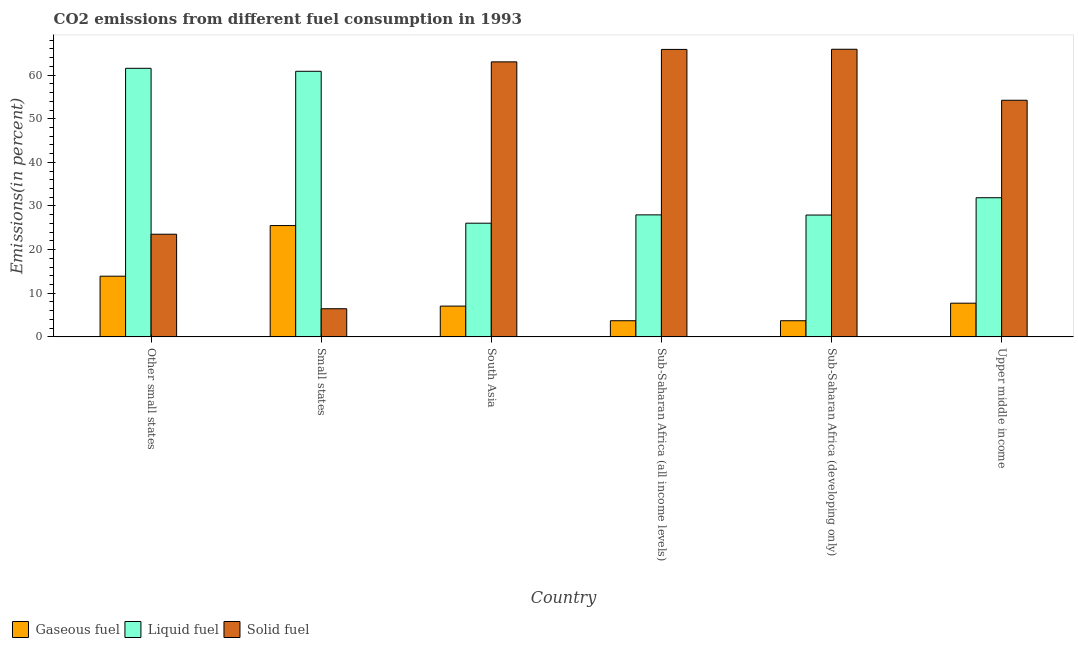Are the number of bars per tick equal to the number of legend labels?
Provide a short and direct response. Yes. In how many cases, is the number of bars for a given country not equal to the number of legend labels?
Offer a very short reply. 0. What is the percentage of gaseous fuel emission in Sub-Saharan Africa (all income levels)?
Make the answer very short. 3.7. Across all countries, what is the maximum percentage of liquid fuel emission?
Provide a short and direct response. 61.56. Across all countries, what is the minimum percentage of solid fuel emission?
Ensure brevity in your answer.  6.45. In which country was the percentage of liquid fuel emission maximum?
Ensure brevity in your answer.  Other small states. In which country was the percentage of gaseous fuel emission minimum?
Offer a terse response. Sub-Saharan Africa (all income levels). What is the total percentage of gaseous fuel emission in the graph?
Offer a very short reply. 61.59. What is the difference between the percentage of solid fuel emission in Sub-Saharan Africa (all income levels) and that in Sub-Saharan Africa (developing only)?
Make the answer very short. -0.04. What is the difference between the percentage of gaseous fuel emission in Sub-Saharan Africa (all income levels) and the percentage of solid fuel emission in Sub-Saharan Africa (developing only)?
Your answer should be compact. -62.22. What is the average percentage of gaseous fuel emission per country?
Your answer should be very brief. 10.27. What is the difference between the percentage of gaseous fuel emission and percentage of solid fuel emission in Small states?
Your response must be concise. 19.06. What is the ratio of the percentage of solid fuel emission in Sub-Saharan Africa (developing only) to that in Upper middle income?
Offer a terse response. 1.22. Is the difference between the percentage of gaseous fuel emission in Small states and South Asia greater than the difference between the percentage of liquid fuel emission in Small states and South Asia?
Make the answer very short. No. What is the difference between the highest and the second highest percentage of liquid fuel emission?
Your answer should be compact. 0.69. What is the difference between the highest and the lowest percentage of solid fuel emission?
Ensure brevity in your answer.  59.48. In how many countries, is the percentage of gaseous fuel emission greater than the average percentage of gaseous fuel emission taken over all countries?
Your answer should be very brief. 2. Is the sum of the percentage of liquid fuel emission in Sub-Saharan Africa (developing only) and Upper middle income greater than the maximum percentage of gaseous fuel emission across all countries?
Offer a very short reply. Yes. What does the 3rd bar from the left in Sub-Saharan Africa (developing only) represents?
Make the answer very short. Solid fuel. What does the 3rd bar from the right in Sub-Saharan Africa (developing only) represents?
Offer a terse response. Gaseous fuel. Is it the case that in every country, the sum of the percentage of gaseous fuel emission and percentage of liquid fuel emission is greater than the percentage of solid fuel emission?
Provide a succinct answer. No. Are all the bars in the graph horizontal?
Give a very brief answer. No. How many countries are there in the graph?
Your answer should be very brief. 6. What is the difference between two consecutive major ticks on the Y-axis?
Your answer should be very brief. 10. Are the values on the major ticks of Y-axis written in scientific E-notation?
Ensure brevity in your answer.  No. Does the graph contain grids?
Your answer should be very brief. No. How are the legend labels stacked?
Offer a very short reply. Horizontal. What is the title of the graph?
Provide a succinct answer. CO2 emissions from different fuel consumption in 1993. Does "Resident buildings and public services" appear as one of the legend labels in the graph?
Give a very brief answer. No. What is the label or title of the X-axis?
Keep it short and to the point. Country. What is the label or title of the Y-axis?
Keep it short and to the point. Emissions(in percent). What is the Emissions(in percent) of Gaseous fuel in Other small states?
Give a very brief answer. 13.91. What is the Emissions(in percent) of Liquid fuel in Other small states?
Ensure brevity in your answer.  61.56. What is the Emissions(in percent) of Solid fuel in Other small states?
Offer a very short reply. 23.53. What is the Emissions(in percent) in Gaseous fuel in Small states?
Your answer should be compact. 25.51. What is the Emissions(in percent) of Liquid fuel in Small states?
Your answer should be very brief. 60.87. What is the Emissions(in percent) in Solid fuel in Small states?
Keep it short and to the point. 6.45. What is the Emissions(in percent) of Gaseous fuel in South Asia?
Give a very brief answer. 7.05. What is the Emissions(in percent) in Liquid fuel in South Asia?
Provide a short and direct response. 26.05. What is the Emissions(in percent) of Solid fuel in South Asia?
Ensure brevity in your answer.  63.03. What is the Emissions(in percent) in Gaseous fuel in Sub-Saharan Africa (all income levels)?
Your response must be concise. 3.7. What is the Emissions(in percent) in Liquid fuel in Sub-Saharan Africa (all income levels)?
Provide a succinct answer. 27.96. What is the Emissions(in percent) in Solid fuel in Sub-Saharan Africa (all income levels)?
Your answer should be very brief. 65.89. What is the Emissions(in percent) in Gaseous fuel in Sub-Saharan Africa (developing only)?
Offer a very short reply. 3.7. What is the Emissions(in percent) in Liquid fuel in Sub-Saharan Africa (developing only)?
Provide a short and direct response. 27.92. What is the Emissions(in percent) of Solid fuel in Sub-Saharan Africa (developing only)?
Keep it short and to the point. 65.92. What is the Emissions(in percent) of Gaseous fuel in Upper middle income?
Give a very brief answer. 7.72. What is the Emissions(in percent) of Liquid fuel in Upper middle income?
Ensure brevity in your answer.  31.89. What is the Emissions(in percent) of Solid fuel in Upper middle income?
Provide a short and direct response. 54.23. Across all countries, what is the maximum Emissions(in percent) of Gaseous fuel?
Your answer should be very brief. 25.51. Across all countries, what is the maximum Emissions(in percent) in Liquid fuel?
Make the answer very short. 61.56. Across all countries, what is the maximum Emissions(in percent) of Solid fuel?
Your response must be concise. 65.92. Across all countries, what is the minimum Emissions(in percent) in Gaseous fuel?
Keep it short and to the point. 3.7. Across all countries, what is the minimum Emissions(in percent) of Liquid fuel?
Offer a very short reply. 26.05. Across all countries, what is the minimum Emissions(in percent) of Solid fuel?
Provide a succinct answer. 6.45. What is the total Emissions(in percent) of Gaseous fuel in the graph?
Make the answer very short. 61.59. What is the total Emissions(in percent) of Liquid fuel in the graph?
Your response must be concise. 236.27. What is the total Emissions(in percent) in Solid fuel in the graph?
Your response must be concise. 279.05. What is the difference between the Emissions(in percent) of Gaseous fuel in Other small states and that in Small states?
Offer a very short reply. -11.6. What is the difference between the Emissions(in percent) in Liquid fuel in Other small states and that in Small states?
Offer a very short reply. 0.69. What is the difference between the Emissions(in percent) of Solid fuel in Other small states and that in Small states?
Ensure brevity in your answer.  17.08. What is the difference between the Emissions(in percent) of Gaseous fuel in Other small states and that in South Asia?
Offer a very short reply. 6.85. What is the difference between the Emissions(in percent) of Liquid fuel in Other small states and that in South Asia?
Your response must be concise. 35.5. What is the difference between the Emissions(in percent) of Solid fuel in Other small states and that in South Asia?
Keep it short and to the point. -39.51. What is the difference between the Emissions(in percent) of Gaseous fuel in Other small states and that in Sub-Saharan Africa (all income levels)?
Provide a short and direct response. 10.21. What is the difference between the Emissions(in percent) of Liquid fuel in Other small states and that in Sub-Saharan Africa (all income levels)?
Your answer should be very brief. 33.59. What is the difference between the Emissions(in percent) in Solid fuel in Other small states and that in Sub-Saharan Africa (all income levels)?
Your answer should be compact. -42.36. What is the difference between the Emissions(in percent) in Gaseous fuel in Other small states and that in Sub-Saharan Africa (developing only)?
Keep it short and to the point. 10.21. What is the difference between the Emissions(in percent) in Liquid fuel in Other small states and that in Sub-Saharan Africa (developing only)?
Ensure brevity in your answer.  33.63. What is the difference between the Emissions(in percent) in Solid fuel in Other small states and that in Sub-Saharan Africa (developing only)?
Your response must be concise. -42.4. What is the difference between the Emissions(in percent) in Gaseous fuel in Other small states and that in Upper middle income?
Your answer should be very brief. 6.18. What is the difference between the Emissions(in percent) of Liquid fuel in Other small states and that in Upper middle income?
Keep it short and to the point. 29.66. What is the difference between the Emissions(in percent) of Solid fuel in Other small states and that in Upper middle income?
Make the answer very short. -30.71. What is the difference between the Emissions(in percent) of Gaseous fuel in Small states and that in South Asia?
Your answer should be compact. 18.46. What is the difference between the Emissions(in percent) of Liquid fuel in Small states and that in South Asia?
Offer a very short reply. 34.82. What is the difference between the Emissions(in percent) in Solid fuel in Small states and that in South Asia?
Keep it short and to the point. -56.59. What is the difference between the Emissions(in percent) of Gaseous fuel in Small states and that in Sub-Saharan Africa (all income levels)?
Give a very brief answer. 21.81. What is the difference between the Emissions(in percent) in Liquid fuel in Small states and that in Sub-Saharan Africa (all income levels)?
Make the answer very short. 32.91. What is the difference between the Emissions(in percent) in Solid fuel in Small states and that in Sub-Saharan Africa (all income levels)?
Your response must be concise. -59.44. What is the difference between the Emissions(in percent) in Gaseous fuel in Small states and that in Sub-Saharan Africa (developing only)?
Provide a short and direct response. 21.81. What is the difference between the Emissions(in percent) in Liquid fuel in Small states and that in Sub-Saharan Africa (developing only)?
Your answer should be compact. 32.95. What is the difference between the Emissions(in percent) in Solid fuel in Small states and that in Sub-Saharan Africa (developing only)?
Keep it short and to the point. -59.48. What is the difference between the Emissions(in percent) in Gaseous fuel in Small states and that in Upper middle income?
Offer a very short reply. 17.79. What is the difference between the Emissions(in percent) of Liquid fuel in Small states and that in Upper middle income?
Offer a very short reply. 28.98. What is the difference between the Emissions(in percent) in Solid fuel in Small states and that in Upper middle income?
Your answer should be very brief. -47.79. What is the difference between the Emissions(in percent) of Gaseous fuel in South Asia and that in Sub-Saharan Africa (all income levels)?
Give a very brief answer. 3.35. What is the difference between the Emissions(in percent) of Liquid fuel in South Asia and that in Sub-Saharan Africa (all income levels)?
Provide a short and direct response. -1.91. What is the difference between the Emissions(in percent) of Solid fuel in South Asia and that in Sub-Saharan Africa (all income levels)?
Make the answer very short. -2.85. What is the difference between the Emissions(in percent) in Gaseous fuel in South Asia and that in Sub-Saharan Africa (developing only)?
Your answer should be compact. 3.35. What is the difference between the Emissions(in percent) in Liquid fuel in South Asia and that in Sub-Saharan Africa (developing only)?
Your answer should be compact. -1.87. What is the difference between the Emissions(in percent) of Solid fuel in South Asia and that in Sub-Saharan Africa (developing only)?
Your answer should be compact. -2.89. What is the difference between the Emissions(in percent) in Gaseous fuel in South Asia and that in Upper middle income?
Make the answer very short. -0.67. What is the difference between the Emissions(in percent) in Liquid fuel in South Asia and that in Upper middle income?
Your answer should be compact. -5.84. What is the difference between the Emissions(in percent) in Solid fuel in South Asia and that in Upper middle income?
Give a very brief answer. 8.8. What is the difference between the Emissions(in percent) in Gaseous fuel in Sub-Saharan Africa (all income levels) and that in Sub-Saharan Africa (developing only)?
Keep it short and to the point. -0. What is the difference between the Emissions(in percent) of Liquid fuel in Sub-Saharan Africa (all income levels) and that in Sub-Saharan Africa (developing only)?
Make the answer very short. 0.04. What is the difference between the Emissions(in percent) of Solid fuel in Sub-Saharan Africa (all income levels) and that in Sub-Saharan Africa (developing only)?
Give a very brief answer. -0.04. What is the difference between the Emissions(in percent) in Gaseous fuel in Sub-Saharan Africa (all income levels) and that in Upper middle income?
Give a very brief answer. -4.02. What is the difference between the Emissions(in percent) of Liquid fuel in Sub-Saharan Africa (all income levels) and that in Upper middle income?
Provide a succinct answer. -3.93. What is the difference between the Emissions(in percent) of Solid fuel in Sub-Saharan Africa (all income levels) and that in Upper middle income?
Provide a succinct answer. 11.65. What is the difference between the Emissions(in percent) in Gaseous fuel in Sub-Saharan Africa (developing only) and that in Upper middle income?
Make the answer very short. -4.02. What is the difference between the Emissions(in percent) of Liquid fuel in Sub-Saharan Africa (developing only) and that in Upper middle income?
Ensure brevity in your answer.  -3.97. What is the difference between the Emissions(in percent) in Solid fuel in Sub-Saharan Africa (developing only) and that in Upper middle income?
Ensure brevity in your answer.  11.69. What is the difference between the Emissions(in percent) in Gaseous fuel in Other small states and the Emissions(in percent) in Liquid fuel in Small states?
Your answer should be compact. -46.97. What is the difference between the Emissions(in percent) of Gaseous fuel in Other small states and the Emissions(in percent) of Solid fuel in Small states?
Your response must be concise. 7.46. What is the difference between the Emissions(in percent) in Liquid fuel in Other small states and the Emissions(in percent) in Solid fuel in Small states?
Provide a short and direct response. 55.11. What is the difference between the Emissions(in percent) of Gaseous fuel in Other small states and the Emissions(in percent) of Liquid fuel in South Asia?
Keep it short and to the point. -12.15. What is the difference between the Emissions(in percent) of Gaseous fuel in Other small states and the Emissions(in percent) of Solid fuel in South Asia?
Offer a terse response. -49.13. What is the difference between the Emissions(in percent) in Liquid fuel in Other small states and the Emissions(in percent) in Solid fuel in South Asia?
Keep it short and to the point. -1.48. What is the difference between the Emissions(in percent) in Gaseous fuel in Other small states and the Emissions(in percent) in Liquid fuel in Sub-Saharan Africa (all income levels)?
Your response must be concise. -14.06. What is the difference between the Emissions(in percent) of Gaseous fuel in Other small states and the Emissions(in percent) of Solid fuel in Sub-Saharan Africa (all income levels)?
Your answer should be compact. -51.98. What is the difference between the Emissions(in percent) of Liquid fuel in Other small states and the Emissions(in percent) of Solid fuel in Sub-Saharan Africa (all income levels)?
Give a very brief answer. -4.33. What is the difference between the Emissions(in percent) of Gaseous fuel in Other small states and the Emissions(in percent) of Liquid fuel in Sub-Saharan Africa (developing only)?
Your answer should be very brief. -14.02. What is the difference between the Emissions(in percent) of Gaseous fuel in Other small states and the Emissions(in percent) of Solid fuel in Sub-Saharan Africa (developing only)?
Make the answer very short. -52.02. What is the difference between the Emissions(in percent) of Liquid fuel in Other small states and the Emissions(in percent) of Solid fuel in Sub-Saharan Africa (developing only)?
Your answer should be compact. -4.37. What is the difference between the Emissions(in percent) in Gaseous fuel in Other small states and the Emissions(in percent) in Liquid fuel in Upper middle income?
Your answer should be very brief. -17.99. What is the difference between the Emissions(in percent) in Gaseous fuel in Other small states and the Emissions(in percent) in Solid fuel in Upper middle income?
Ensure brevity in your answer.  -40.33. What is the difference between the Emissions(in percent) of Liquid fuel in Other small states and the Emissions(in percent) of Solid fuel in Upper middle income?
Ensure brevity in your answer.  7.32. What is the difference between the Emissions(in percent) of Gaseous fuel in Small states and the Emissions(in percent) of Liquid fuel in South Asia?
Provide a short and direct response. -0.54. What is the difference between the Emissions(in percent) of Gaseous fuel in Small states and the Emissions(in percent) of Solid fuel in South Asia?
Provide a short and direct response. -37.52. What is the difference between the Emissions(in percent) in Liquid fuel in Small states and the Emissions(in percent) in Solid fuel in South Asia?
Provide a succinct answer. -2.16. What is the difference between the Emissions(in percent) in Gaseous fuel in Small states and the Emissions(in percent) in Liquid fuel in Sub-Saharan Africa (all income levels)?
Offer a terse response. -2.45. What is the difference between the Emissions(in percent) of Gaseous fuel in Small states and the Emissions(in percent) of Solid fuel in Sub-Saharan Africa (all income levels)?
Ensure brevity in your answer.  -40.38. What is the difference between the Emissions(in percent) of Liquid fuel in Small states and the Emissions(in percent) of Solid fuel in Sub-Saharan Africa (all income levels)?
Your answer should be compact. -5.01. What is the difference between the Emissions(in percent) of Gaseous fuel in Small states and the Emissions(in percent) of Liquid fuel in Sub-Saharan Africa (developing only)?
Your response must be concise. -2.41. What is the difference between the Emissions(in percent) in Gaseous fuel in Small states and the Emissions(in percent) in Solid fuel in Sub-Saharan Africa (developing only)?
Your response must be concise. -40.41. What is the difference between the Emissions(in percent) of Liquid fuel in Small states and the Emissions(in percent) of Solid fuel in Sub-Saharan Africa (developing only)?
Ensure brevity in your answer.  -5.05. What is the difference between the Emissions(in percent) of Gaseous fuel in Small states and the Emissions(in percent) of Liquid fuel in Upper middle income?
Your response must be concise. -6.38. What is the difference between the Emissions(in percent) in Gaseous fuel in Small states and the Emissions(in percent) in Solid fuel in Upper middle income?
Your answer should be compact. -28.72. What is the difference between the Emissions(in percent) in Liquid fuel in Small states and the Emissions(in percent) in Solid fuel in Upper middle income?
Provide a short and direct response. 6.64. What is the difference between the Emissions(in percent) in Gaseous fuel in South Asia and the Emissions(in percent) in Liquid fuel in Sub-Saharan Africa (all income levels)?
Make the answer very short. -20.91. What is the difference between the Emissions(in percent) of Gaseous fuel in South Asia and the Emissions(in percent) of Solid fuel in Sub-Saharan Africa (all income levels)?
Offer a very short reply. -58.83. What is the difference between the Emissions(in percent) of Liquid fuel in South Asia and the Emissions(in percent) of Solid fuel in Sub-Saharan Africa (all income levels)?
Ensure brevity in your answer.  -39.83. What is the difference between the Emissions(in percent) of Gaseous fuel in South Asia and the Emissions(in percent) of Liquid fuel in Sub-Saharan Africa (developing only)?
Offer a terse response. -20.87. What is the difference between the Emissions(in percent) in Gaseous fuel in South Asia and the Emissions(in percent) in Solid fuel in Sub-Saharan Africa (developing only)?
Keep it short and to the point. -58.87. What is the difference between the Emissions(in percent) in Liquid fuel in South Asia and the Emissions(in percent) in Solid fuel in Sub-Saharan Africa (developing only)?
Give a very brief answer. -39.87. What is the difference between the Emissions(in percent) in Gaseous fuel in South Asia and the Emissions(in percent) in Liquid fuel in Upper middle income?
Offer a terse response. -24.84. What is the difference between the Emissions(in percent) of Gaseous fuel in South Asia and the Emissions(in percent) of Solid fuel in Upper middle income?
Provide a short and direct response. -47.18. What is the difference between the Emissions(in percent) in Liquid fuel in South Asia and the Emissions(in percent) in Solid fuel in Upper middle income?
Provide a succinct answer. -28.18. What is the difference between the Emissions(in percent) of Gaseous fuel in Sub-Saharan Africa (all income levels) and the Emissions(in percent) of Liquid fuel in Sub-Saharan Africa (developing only)?
Give a very brief answer. -24.22. What is the difference between the Emissions(in percent) in Gaseous fuel in Sub-Saharan Africa (all income levels) and the Emissions(in percent) in Solid fuel in Sub-Saharan Africa (developing only)?
Offer a terse response. -62.22. What is the difference between the Emissions(in percent) in Liquid fuel in Sub-Saharan Africa (all income levels) and the Emissions(in percent) in Solid fuel in Sub-Saharan Africa (developing only)?
Offer a terse response. -37.96. What is the difference between the Emissions(in percent) in Gaseous fuel in Sub-Saharan Africa (all income levels) and the Emissions(in percent) in Liquid fuel in Upper middle income?
Your response must be concise. -28.19. What is the difference between the Emissions(in percent) in Gaseous fuel in Sub-Saharan Africa (all income levels) and the Emissions(in percent) in Solid fuel in Upper middle income?
Make the answer very short. -50.53. What is the difference between the Emissions(in percent) in Liquid fuel in Sub-Saharan Africa (all income levels) and the Emissions(in percent) in Solid fuel in Upper middle income?
Offer a terse response. -26.27. What is the difference between the Emissions(in percent) of Gaseous fuel in Sub-Saharan Africa (developing only) and the Emissions(in percent) of Liquid fuel in Upper middle income?
Offer a terse response. -28.19. What is the difference between the Emissions(in percent) in Gaseous fuel in Sub-Saharan Africa (developing only) and the Emissions(in percent) in Solid fuel in Upper middle income?
Offer a terse response. -50.53. What is the difference between the Emissions(in percent) in Liquid fuel in Sub-Saharan Africa (developing only) and the Emissions(in percent) in Solid fuel in Upper middle income?
Make the answer very short. -26.31. What is the average Emissions(in percent) of Gaseous fuel per country?
Your answer should be compact. 10.27. What is the average Emissions(in percent) in Liquid fuel per country?
Provide a succinct answer. 39.38. What is the average Emissions(in percent) of Solid fuel per country?
Your answer should be compact. 46.51. What is the difference between the Emissions(in percent) of Gaseous fuel and Emissions(in percent) of Liquid fuel in Other small states?
Your response must be concise. -47.65. What is the difference between the Emissions(in percent) in Gaseous fuel and Emissions(in percent) in Solid fuel in Other small states?
Your answer should be compact. -9.62. What is the difference between the Emissions(in percent) in Liquid fuel and Emissions(in percent) in Solid fuel in Other small states?
Provide a short and direct response. 38.03. What is the difference between the Emissions(in percent) of Gaseous fuel and Emissions(in percent) of Liquid fuel in Small states?
Give a very brief answer. -35.36. What is the difference between the Emissions(in percent) of Gaseous fuel and Emissions(in percent) of Solid fuel in Small states?
Provide a short and direct response. 19.06. What is the difference between the Emissions(in percent) in Liquid fuel and Emissions(in percent) in Solid fuel in Small states?
Your answer should be very brief. 54.43. What is the difference between the Emissions(in percent) of Gaseous fuel and Emissions(in percent) of Liquid fuel in South Asia?
Provide a short and direct response. -19. What is the difference between the Emissions(in percent) in Gaseous fuel and Emissions(in percent) in Solid fuel in South Asia?
Provide a succinct answer. -55.98. What is the difference between the Emissions(in percent) of Liquid fuel and Emissions(in percent) of Solid fuel in South Asia?
Ensure brevity in your answer.  -36.98. What is the difference between the Emissions(in percent) of Gaseous fuel and Emissions(in percent) of Liquid fuel in Sub-Saharan Africa (all income levels)?
Offer a very short reply. -24.27. What is the difference between the Emissions(in percent) of Gaseous fuel and Emissions(in percent) of Solid fuel in Sub-Saharan Africa (all income levels)?
Give a very brief answer. -62.19. What is the difference between the Emissions(in percent) in Liquid fuel and Emissions(in percent) in Solid fuel in Sub-Saharan Africa (all income levels)?
Make the answer very short. -37.92. What is the difference between the Emissions(in percent) of Gaseous fuel and Emissions(in percent) of Liquid fuel in Sub-Saharan Africa (developing only)?
Provide a short and direct response. -24.22. What is the difference between the Emissions(in percent) in Gaseous fuel and Emissions(in percent) in Solid fuel in Sub-Saharan Africa (developing only)?
Keep it short and to the point. -62.22. What is the difference between the Emissions(in percent) of Liquid fuel and Emissions(in percent) of Solid fuel in Sub-Saharan Africa (developing only)?
Offer a very short reply. -38. What is the difference between the Emissions(in percent) in Gaseous fuel and Emissions(in percent) in Liquid fuel in Upper middle income?
Keep it short and to the point. -24.17. What is the difference between the Emissions(in percent) of Gaseous fuel and Emissions(in percent) of Solid fuel in Upper middle income?
Your answer should be compact. -46.51. What is the difference between the Emissions(in percent) of Liquid fuel and Emissions(in percent) of Solid fuel in Upper middle income?
Your answer should be very brief. -22.34. What is the ratio of the Emissions(in percent) of Gaseous fuel in Other small states to that in Small states?
Offer a terse response. 0.55. What is the ratio of the Emissions(in percent) of Liquid fuel in Other small states to that in Small states?
Offer a very short reply. 1.01. What is the ratio of the Emissions(in percent) of Solid fuel in Other small states to that in Small states?
Ensure brevity in your answer.  3.65. What is the ratio of the Emissions(in percent) in Gaseous fuel in Other small states to that in South Asia?
Your response must be concise. 1.97. What is the ratio of the Emissions(in percent) of Liquid fuel in Other small states to that in South Asia?
Keep it short and to the point. 2.36. What is the ratio of the Emissions(in percent) in Solid fuel in Other small states to that in South Asia?
Keep it short and to the point. 0.37. What is the ratio of the Emissions(in percent) of Gaseous fuel in Other small states to that in Sub-Saharan Africa (all income levels)?
Your answer should be very brief. 3.76. What is the ratio of the Emissions(in percent) of Liquid fuel in Other small states to that in Sub-Saharan Africa (all income levels)?
Your answer should be compact. 2.2. What is the ratio of the Emissions(in percent) of Solid fuel in Other small states to that in Sub-Saharan Africa (all income levels)?
Your response must be concise. 0.36. What is the ratio of the Emissions(in percent) in Gaseous fuel in Other small states to that in Sub-Saharan Africa (developing only)?
Your answer should be very brief. 3.76. What is the ratio of the Emissions(in percent) of Liquid fuel in Other small states to that in Sub-Saharan Africa (developing only)?
Offer a very short reply. 2.2. What is the ratio of the Emissions(in percent) in Solid fuel in Other small states to that in Sub-Saharan Africa (developing only)?
Make the answer very short. 0.36. What is the ratio of the Emissions(in percent) in Gaseous fuel in Other small states to that in Upper middle income?
Provide a succinct answer. 1.8. What is the ratio of the Emissions(in percent) of Liquid fuel in Other small states to that in Upper middle income?
Your response must be concise. 1.93. What is the ratio of the Emissions(in percent) of Solid fuel in Other small states to that in Upper middle income?
Your answer should be very brief. 0.43. What is the ratio of the Emissions(in percent) of Gaseous fuel in Small states to that in South Asia?
Keep it short and to the point. 3.62. What is the ratio of the Emissions(in percent) in Liquid fuel in Small states to that in South Asia?
Offer a very short reply. 2.34. What is the ratio of the Emissions(in percent) of Solid fuel in Small states to that in South Asia?
Offer a terse response. 0.1. What is the ratio of the Emissions(in percent) in Gaseous fuel in Small states to that in Sub-Saharan Africa (all income levels)?
Make the answer very short. 6.9. What is the ratio of the Emissions(in percent) of Liquid fuel in Small states to that in Sub-Saharan Africa (all income levels)?
Offer a terse response. 2.18. What is the ratio of the Emissions(in percent) in Solid fuel in Small states to that in Sub-Saharan Africa (all income levels)?
Your response must be concise. 0.1. What is the ratio of the Emissions(in percent) of Gaseous fuel in Small states to that in Sub-Saharan Africa (developing only)?
Provide a short and direct response. 6.89. What is the ratio of the Emissions(in percent) of Liquid fuel in Small states to that in Sub-Saharan Africa (developing only)?
Your answer should be compact. 2.18. What is the ratio of the Emissions(in percent) of Solid fuel in Small states to that in Sub-Saharan Africa (developing only)?
Offer a very short reply. 0.1. What is the ratio of the Emissions(in percent) of Gaseous fuel in Small states to that in Upper middle income?
Your answer should be compact. 3.3. What is the ratio of the Emissions(in percent) of Liquid fuel in Small states to that in Upper middle income?
Your answer should be very brief. 1.91. What is the ratio of the Emissions(in percent) in Solid fuel in Small states to that in Upper middle income?
Ensure brevity in your answer.  0.12. What is the ratio of the Emissions(in percent) of Gaseous fuel in South Asia to that in Sub-Saharan Africa (all income levels)?
Give a very brief answer. 1.91. What is the ratio of the Emissions(in percent) in Liquid fuel in South Asia to that in Sub-Saharan Africa (all income levels)?
Provide a succinct answer. 0.93. What is the ratio of the Emissions(in percent) in Solid fuel in South Asia to that in Sub-Saharan Africa (all income levels)?
Give a very brief answer. 0.96. What is the ratio of the Emissions(in percent) in Gaseous fuel in South Asia to that in Sub-Saharan Africa (developing only)?
Provide a succinct answer. 1.91. What is the ratio of the Emissions(in percent) of Liquid fuel in South Asia to that in Sub-Saharan Africa (developing only)?
Keep it short and to the point. 0.93. What is the ratio of the Emissions(in percent) of Solid fuel in South Asia to that in Sub-Saharan Africa (developing only)?
Your response must be concise. 0.96. What is the ratio of the Emissions(in percent) of Gaseous fuel in South Asia to that in Upper middle income?
Keep it short and to the point. 0.91. What is the ratio of the Emissions(in percent) in Liquid fuel in South Asia to that in Upper middle income?
Offer a terse response. 0.82. What is the ratio of the Emissions(in percent) of Solid fuel in South Asia to that in Upper middle income?
Offer a terse response. 1.16. What is the ratio of the Emissions(in percent) in Gaseous fuel in Sub-Saharan Africa (all income levels) to that in Upper middle income?
Offer a terse response. 0.48. What is the ratio of the Emissions(in percent) in Liquid fuel in Sub-Saharan Africa (all income levels) to that in Upper middle income?
Ensure brevity in your answer.  0.88. What is the ratio of the Emissions(in percent) of Solid fuel in Sub-Saharan Africa (all income levels) to that in Upper middle income?
Your answer should be very brief. 1.21. What is the ratio of the Emissions(in percent) of Gaseous fuel in Sub-Saharan Africa (developing only) to that in Upper middle income?
Your answer should be very brief. 0.48. What is the ratio of the Emissions(in percent) of Liquid fuel in Sub-Saharan Africa (developing only) to that in Upper middle income?
Offer a terse response. 0.88. What is the ratio of the Emissions(in percent) of Solid fuel in Sub-Saharan Africa (developing only) to that in Upper middle income?
Keep it short and to the point. 1.22. What is the difference between the highest and the second highest Emissions(in percent) in Gaseous fuel?
Provide a short and direct response. 11.6. What is the difference between the highest and the second highest Emissions(in percent) in Liquid fuel?
Your answer should be very brief. 0.69. What is the difference between the highest and the second highest Emissions(in percent) of Solid fuel?
Keep it short and to the point. 0.04. What is the difference between the highest and the lowest Emissions(in percent) in Gaseous fuel?
Give a very brief answer. 21.81. What is the difference between the highest and the lowest Emissions(in percent) in Liquid fuel?
Your answer should be very brief. 35.5. What is the difference between the highest and the lowest Emissions(in percent) of Solid fuel?
Make the answer very short. 59.48. 